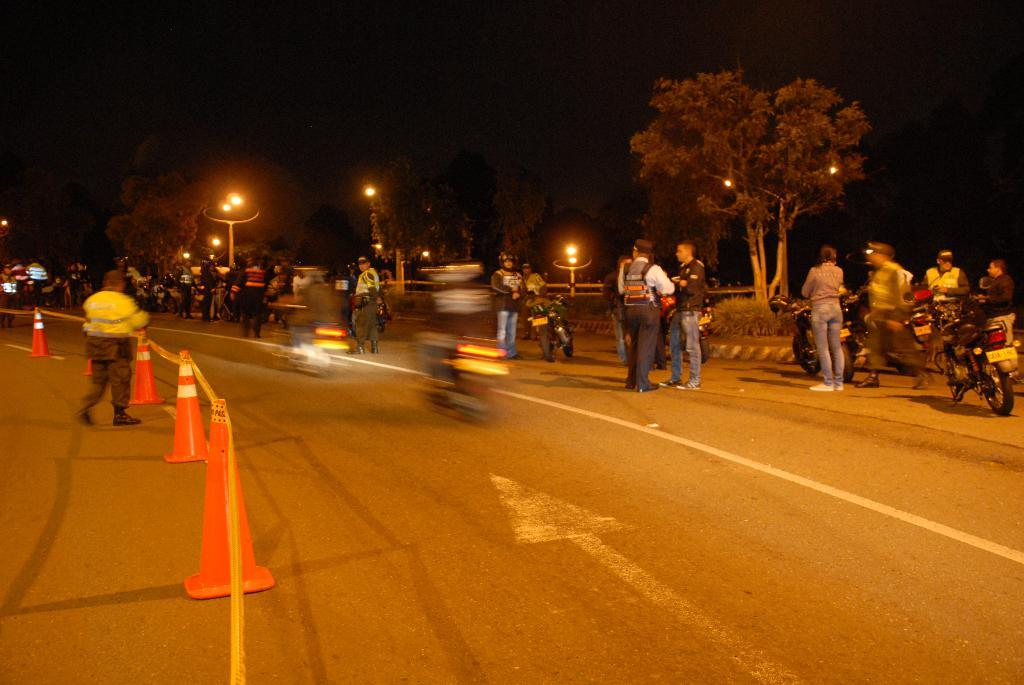What can be seen in the image involving transportation? There are men and bikes in the image. Where are the men and bikes located? The men and bikes are on the road. What can be seen on the left side of the image? Orange color road dividers are on the left side of the image. What is visible in the background of the image? There are trees and lights in the background of the image. What type of oatmeal is being served at the fear-themed restaurant in the image? There is no fear-themed restaurant or oatmeal present in the image. 